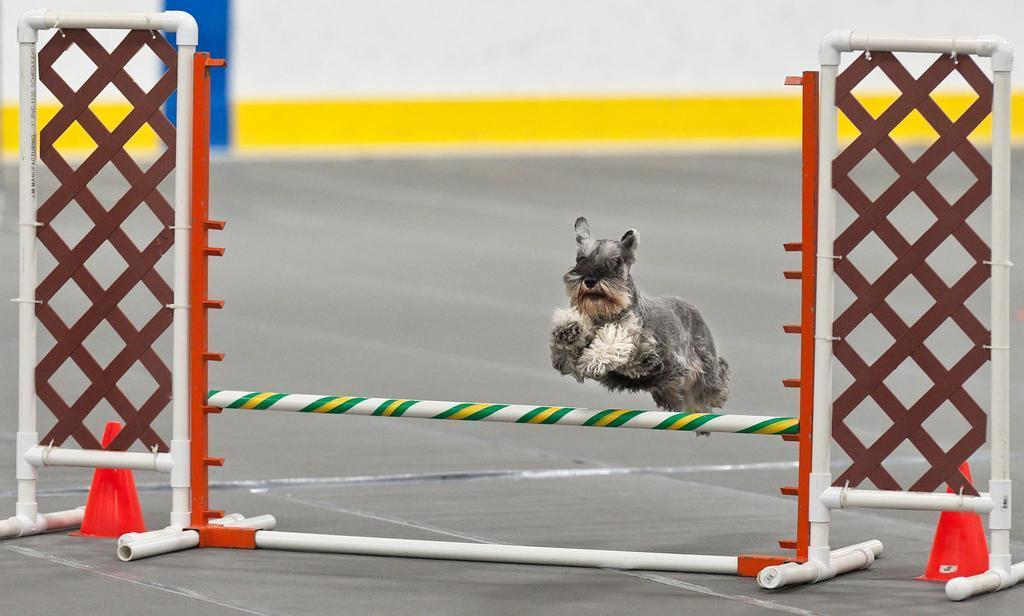Can you describe this image briefly? In this image we can see a dog jumping from the pole. Here we can see the stand and the road cones on the road. The background of the image is slightly blurred, where we can see the wall which is in white, yellow and blue color. 